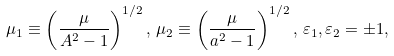<formula> <loc_0><loc_0><loc_500><loc_500>\mu _ { 1 } \equiv \left ( \frac { \mu } { A ^ { 2 } - 1 } \right ) ^ { 1 / 2 } , \, \mu _ { 2 } \equiv \left ( \frac { \mu } { a ^ { 2 } - 1 } \right ) ^ { 1 / 2 } , \, \varepsilon _ { 1 } , \varepsilon _ { 2 } = \pm 1 ,</formula> 